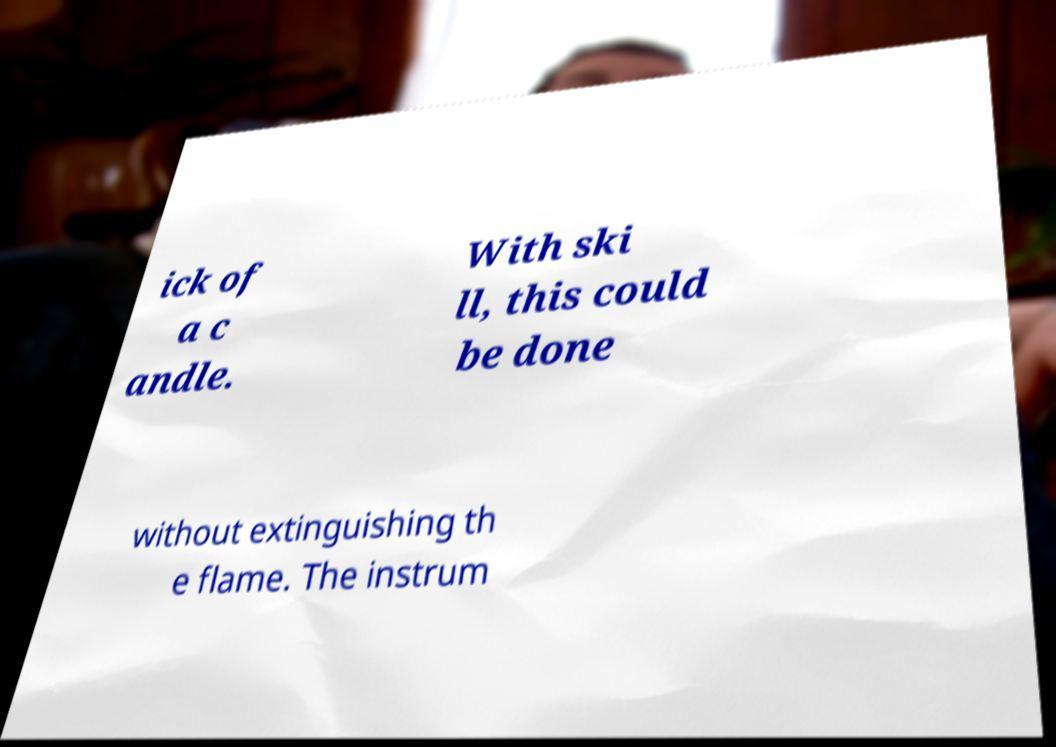For documentation purposes, I need the text within this image transcribed. Could you provide that? ick of a c andle. With ski ll, this could be done without extinguishing th e flame. The instrum 